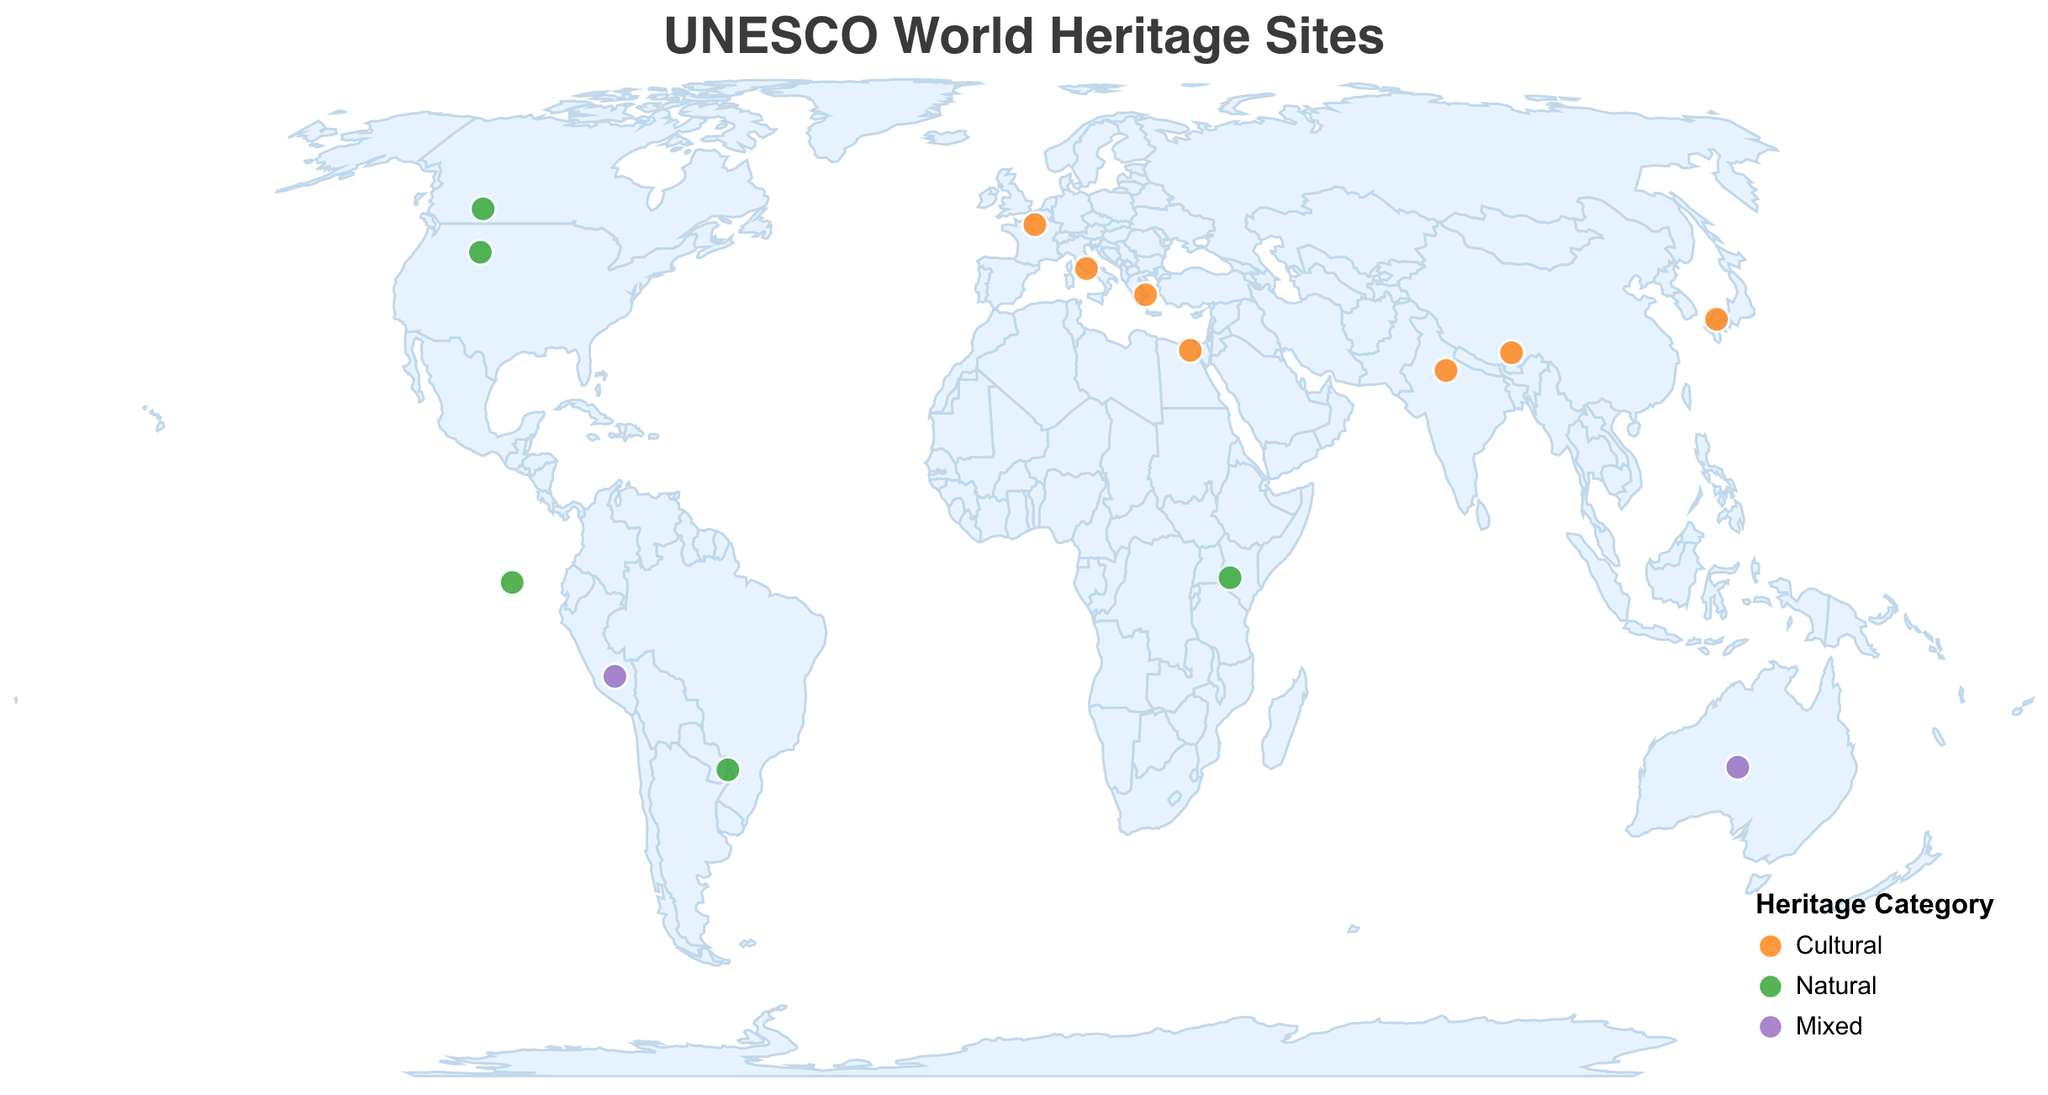what is the title of the plot? The title is located at the top center of the figure. It provides an overview of what the figure represents and is displayed clearly.
Answer: UNESCO World Heritage Sites How many UNESCO World Heritage Sites are classified as "Mixed" in the plot? Look at the color legend that indicates "Mixed" and count the circles of that color.
Answer: 2 Which country has the most natural sites in this plot? Identify the countries with natural sites by looking at the "Natural" color coding and count the occurrences for each country.
Answer: United States and Canada (1 each) What type of UNESCO site is "Historic Centre of Rome"? Find the "Site Name" within the tooltip and check its "Category".
Answer: Cultural Which site is located furthest to the east on the plot? Using the longitude values on the geographic plot, find the site with the highest positive longitude.
Answer: Historic Ensemble of the Potala Palace (China) How many sites have educational value in "Religious Studies and Art"? Check the "Educational Value" for all sites and count the occurrences of "Religious Studies and Art".
Answer: 1 Are there more cultural or natural sites depicted in the figure? Compare the number of circles colored according to the "Cultural" and "Natural" categories.
Answer: Cultural Which site listed under "Natural" is closest to the Equator? Locate the sites classified under "Natural" and compare their latitudes to find the one closest to 0° latitude.
Answer: Galápagos Islands (Ecuador) What category is the Taj Mahal listed under? Using the tooltip feature, identify the "Category" of the Taj Mahal.
Answer: Cultural How many UNESCO sites are represented within Europe on this map? Look for the sites located within the geographic bounds of Europe and count them.
Answer: 3 